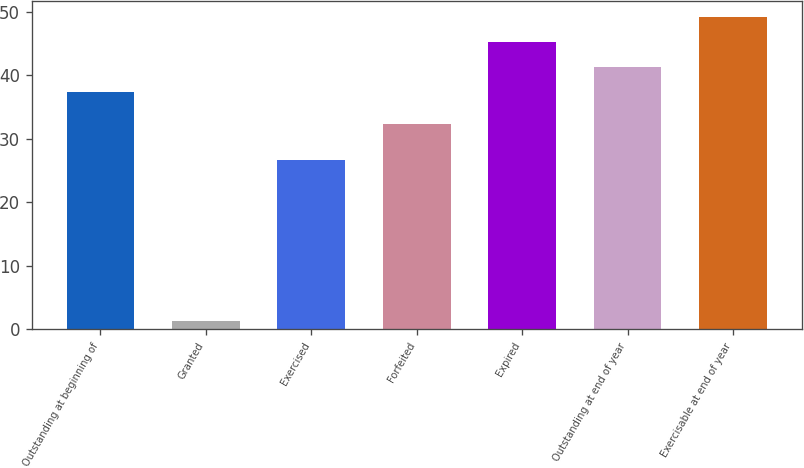<chart> <loc_0><loc_0><loc_500><loc_500><bar_chart><fcel>Outstanding at beginning of<fcel>Granted<fcel>Exercised<fcel>Forfeited<fcel>Expired<fcel>Outstanding at end of year<fcel>Exercisable at end of year<nl><fcel>37.35<fcel>1.25<fcel>26.63<fcel>32.29<fcel>45.27<fcel>41.31<fcel>49.23<nl></chart> 